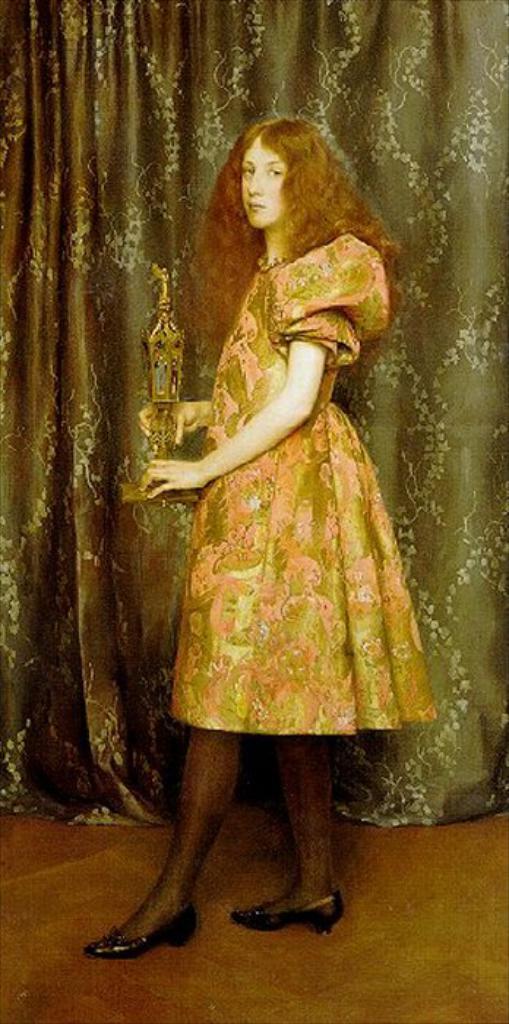Describe this image in one or two sentences. In the picture we can see a woman standing on the path and wearing a dress and holding an award in the background, we can see a curtain with some designs on it. 